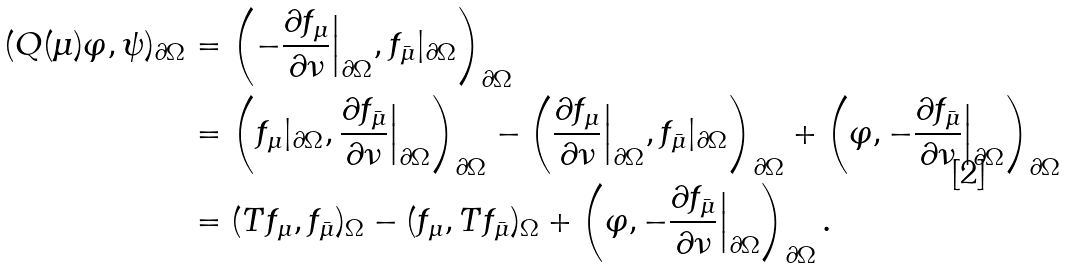Convert formula to latex. <formula><loc_0><loc_0><loc_500><loc_500>( Q ( \mu ) \varphi , \psi ) _ { \partial \Omega } & = \left ( - \frac { \partial f _ { \mu } } { \partial \nu } \Big | _ { \partial \Omega } , f _ { \bar { \mu } } | _ { \partial \Omega } \right ) _ { \partial \Omega } \\ & = \left ( f _ { \mu } | _ { \partial \Omega } , \frac { \partial f _ { \bar { \mu } } } { \partial \nu } \Big | _ { \partial \Omega } \right ) _ { \partial \Omega } - \left ( \frac { \partial f _ { \mu } } { \partial \nu } \Big | _ { \partial \Omega } , f _ { \bar { \mu } } | _ { \partial \Omega } \right ) _ { \partial \Omega } + \left ( \varphi , - \frac { \partial f _ { \bar { \mu } } } { \partial \nu } \Big | _ { \partial \Omega } \right ) _ { \partial \Omega } \\ & = ( T f _ { \mu } , f _ { \bar { \mu } } ) _ { \Omega } - ( f _ { \mu } , T f _ { \bar { \mu } } ) _ { \Omega } + \left ( \varphi , - \frac { \partial f _ { \bar { \mu } } } { \partial \nu } \Big | _ { \partial \Omega } \right ) _ { \partial \Omega } .</formula> 